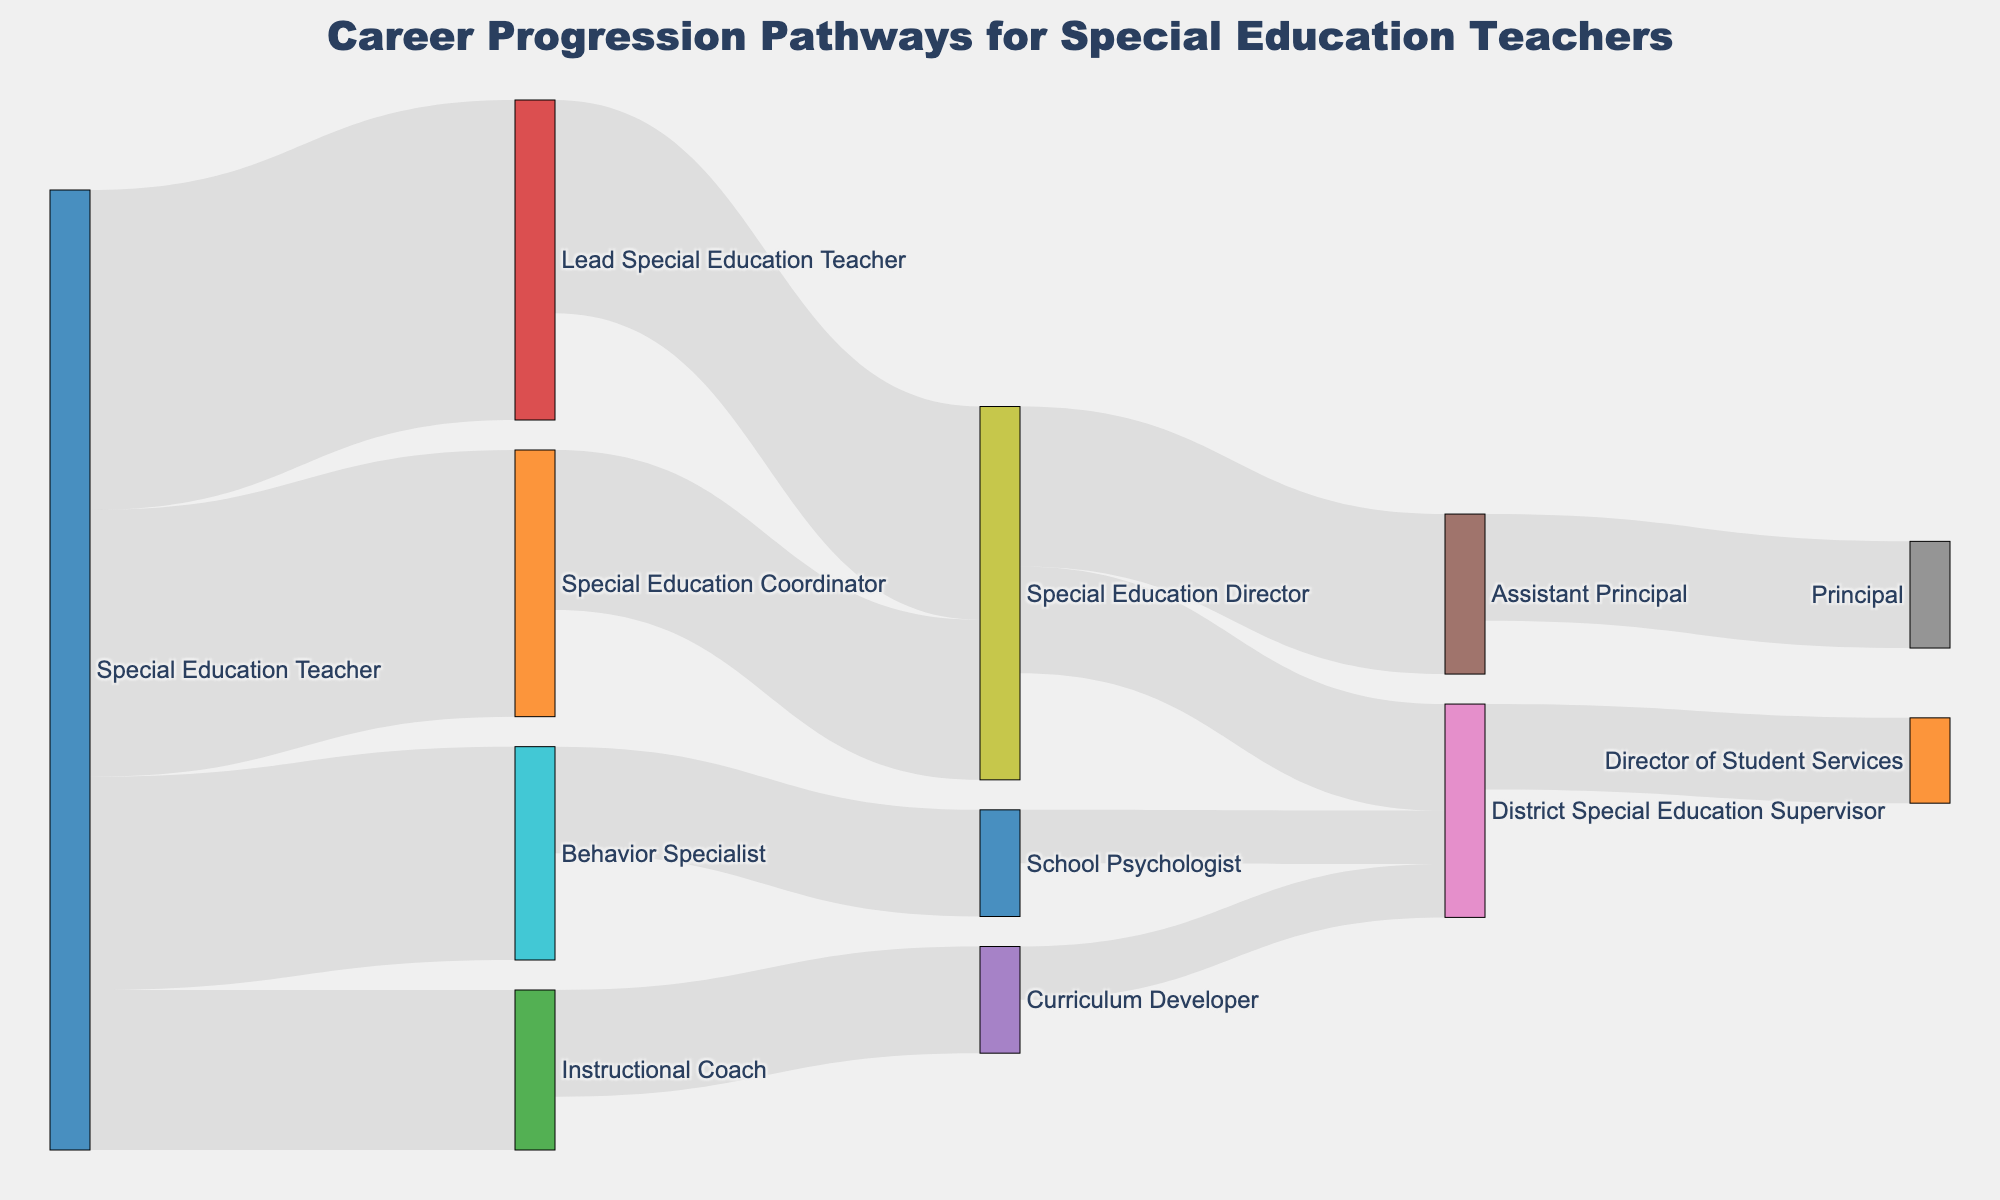What is the title of the diagram? The title of the diagram is displayed prominently at the top of the figure. It reads "Career Progression Pathways for Special Education Teachers."
Answer: Career Progression Pathways for Special Education Teachers How many pathways lead to the "Special Education Director" role? Count the number of direct links (arrows) leading to the "Special Education Director" in the diagram. There are two pathways, from "Lead Special Education Teacher" and "Special Education Coordinator."
Answer: 2 Which role transitions to become an "Assistant Principal"? Look for the node labeled "Assistant Principal" and identify the source of its incoming link. The diagram shows a link from "Special Education Director" to "Assistant Principal."
Answer: Special Education Director What is the total value of teachers progressing from "Special Education Teacher" to "Lead Special Education Teacher" and "Special Education Coordinator"? Sum the values of the transitions from "Special Education Teacher" to "Lead Special Education Teacher" (30) and "Special Education Coordinator" (25). The total value is 30 + 25 = 55.
Answer: 55 Which role has the fewest transitions originating from it? Compare the number of outgoing links (arrows) from each role. The roles "Assistant Principal," "School Psychologist," and "Curriculum Developer" each have the fewest transitions originating from them, with only one outgoing link.
Answer: Assistant Principal, School Psychologist, Curriculum Developer How many roles transition into the "District Special Education Supervisor" role? Identify all the incoming links to the "District Special Education Supervisor" node. There are three roles: "Special Education Director," "School Psychologist," and "Curriculum Developer."
Answer: 3 Which roles transition into "Principal"? Find the node labeled "Principal" and identify the source node of its incoming link. The diagram shows a link from "Assistant Principal" to "Principal."
Answer: Assistant Principal Compare the number of teachers progressing to "Behavior Specialist" and "Instructional Coach." Which has more and by how much? Identify the values of the transitions from "Special Education Teacher" to "Behavior Specialist" (20) and "Instructional Coach" (15). The difference is 20 - 15 = 5, with "Behavior Specialist" having 5 more.
Answer: Behavior Specialist, by 5 What is the ultimate role that "School Psychologist" can transition to according to the diagram? Follow the path originating from "School Psychologist." It leads to "District Special Education Supervisor."
Answer: District Special Education Supervisor Count the total number of distinct roles mentioned in the diagram. Identify and count all unique roles listed as either source or target nodes in the diagram. There are 12 distinct roles.
Answer: 12 